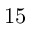<formula> <loc_0><loc_0><loc_500><loc_500>1 5</formula> 